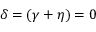<formula> <loc_0><loc_0><loc_500><loc_500>\delta = ( \gamma + \eta ) = 0</formula> 